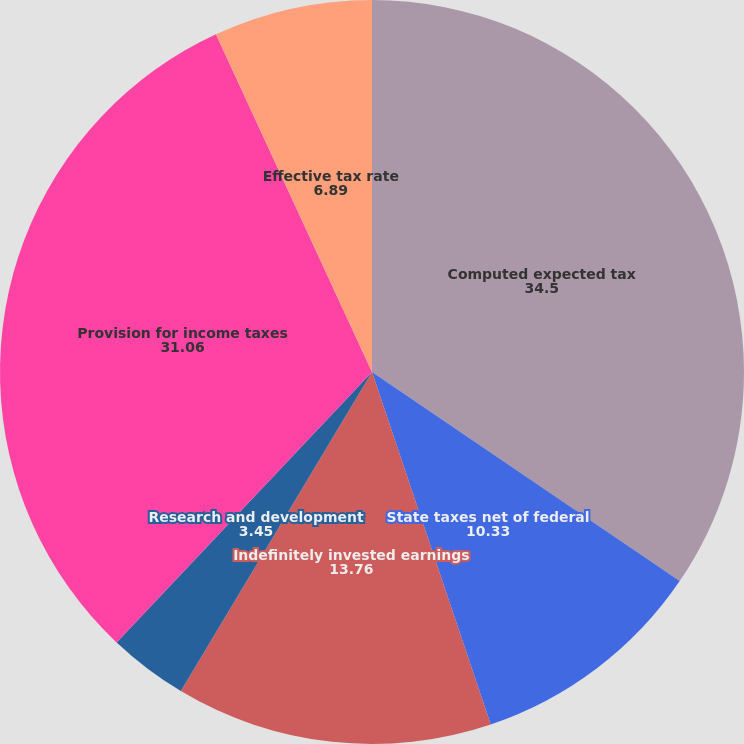<chart> <loc_0><loc_0><loc_500><loc_500><pie_chart><fcel>Computed expected tax<fcel>State taxes net of federal<fcel>Indefinitely invested earnings<fcel>Research and development<fcel>Other<fcel>Provision for income taxes<fcel>Effective tax rate<nl><fcel>34.5%<fcel>10.33%<fcel>13.76%<fcel>3.45%<fcel>0.01%<fcel>31.06%<fcel>6.89%<nl></chart> 